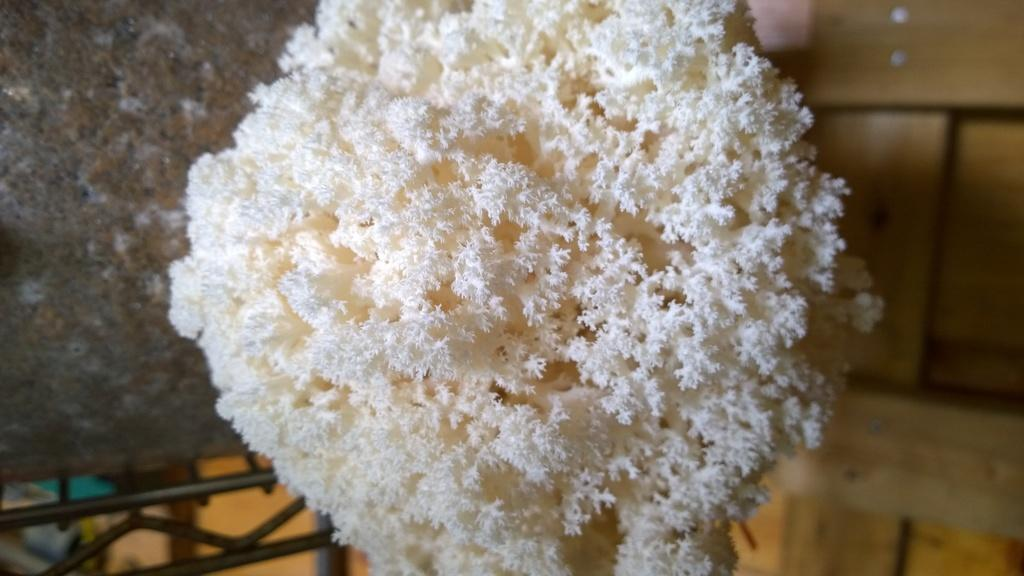What can be seen in the image? There is an object in the image. What is the color of the object? The object is white in color. What type of jelly is being used to act as a hopeful barrier in the image? There is no jelly or barrier present in the image; it only features a white object. 